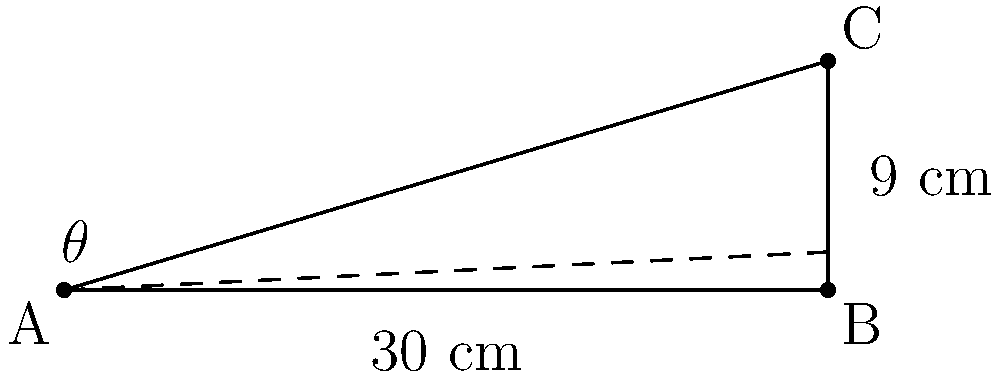In designing a traditional Greenlandic qajaq (kayak), the angle of inclination for the bow is crucial for its performance. If the base of the qajaq's bow is 30 cm long and the height of the tip is 9 cm, what is the angle of inclination ($\theta$) of the bow? To find the angle of inclination ($\theta$), we can use the tangent trigonometric ratio. Here's how:

1) In the right triangle formed by the qajaq's bow:
   - The adjacent side (base) is 30 cm
   - The opposite side (height) is 9 cm

2) The tangent of an angle is defined as the ratio of the opposite side to the adjacent side:

   $\tan(\theta) = \frac{\text{opposite}}{\text{adjacent}} = \frac{9}{30}$

3) Simplify the fraction:
   $\tan(\theta) = \frac{3}{10}$

4) To find $\theta$, we need to use the inverse tangent (arctangent) function:

   $\theta = \tan^{-1}(\frac{3}{10})$

5) Using a calculator or trigonometric tables:

   $\theta \approx 16.70^\circ$

6) Round to the nearest degree:

   $\theta \approx 17^\circ$

Thus, the angle of inclination for the qajaq's bow is approximately 17 degrees.
Answer: $17^\circ$ 